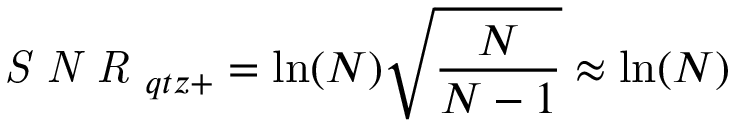<formula> <loc_0><loc_0><loc_500><loc_500>S N R _ { q t z + } = \ln ( N ) \sqrt { \frac { N } { N - 1 } } \approx \ln ( N )</formula> 